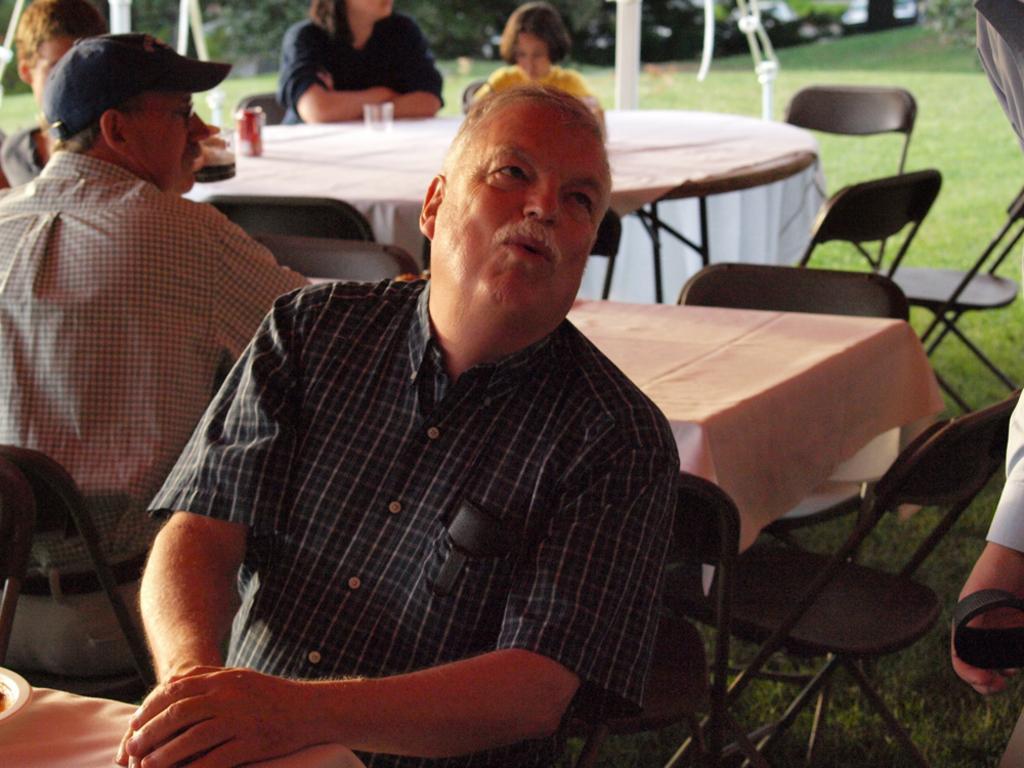Could you give a brief overview of what you see in this image? This image consists of a group of people sitting on the chair, in front of the table, at dining table where glass, juice can is kept. On both side of the image there are trees visible and a grass visible. This image is taken during day time in a lawn area. 